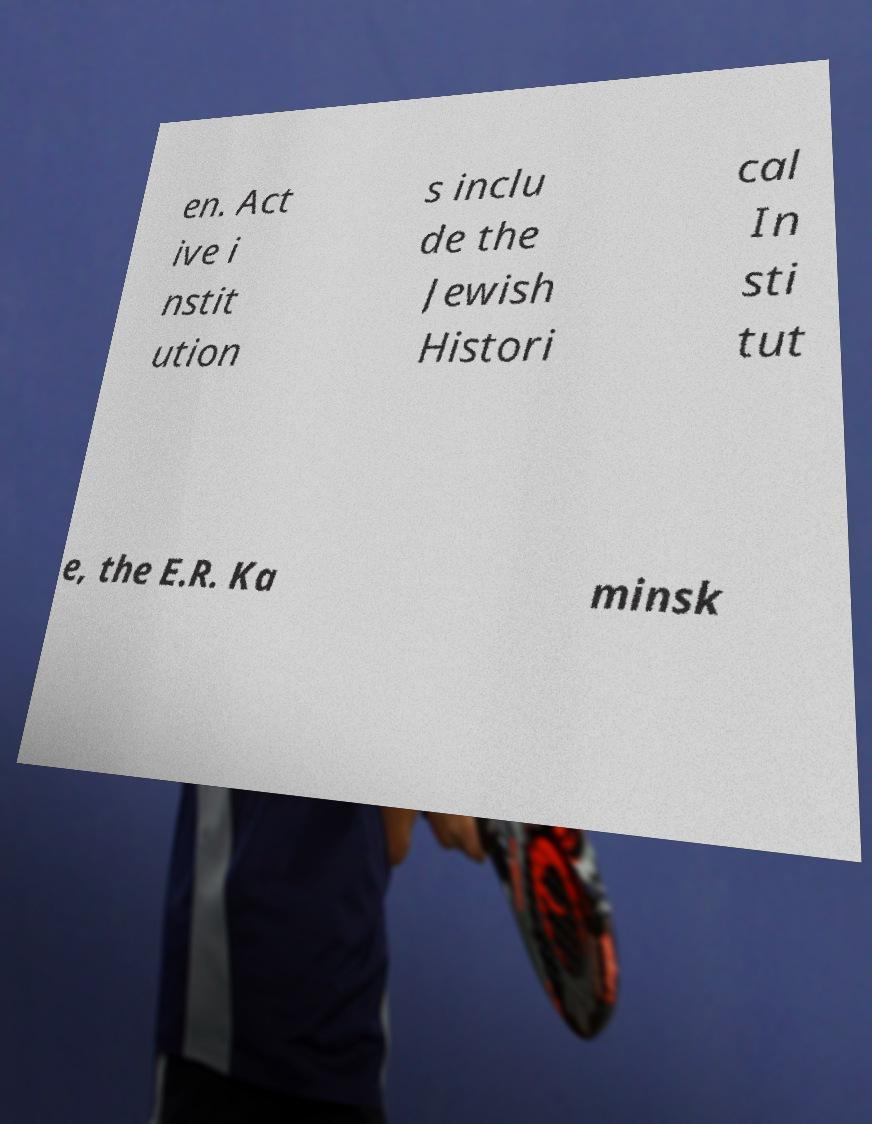Could you extract and type out the text from this image? en. Act ive i nstit ution s inclu de the Jewish Histori cal In sti tut e, the E.R. Ka minsk 